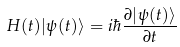Convert formula to latex. <formula><loc_0><loc_0><loc_500><loc_500>H ( t ) | \psi ( t ) \rangle = i \hbar { \frac { \partial | \psi ( t ) \rangle } { \partial t } }</formula> 